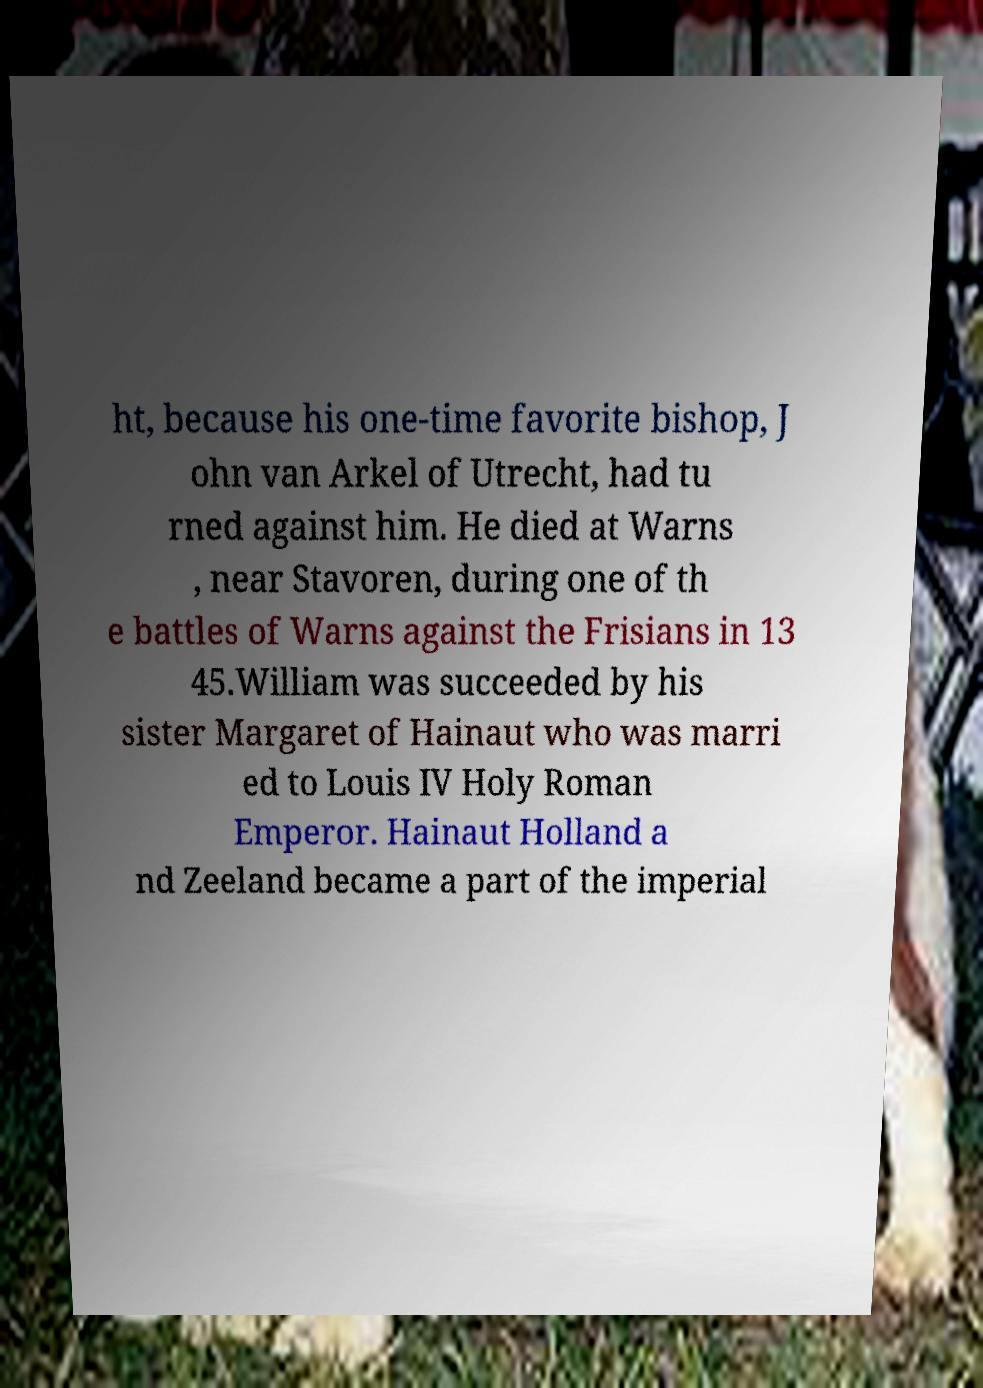There's text embedded in this image that I need extracted. Can you transcribe it verbatim? ht, because his one-time favorite bishop, J ohn van Arkel of Utrecht, had tu rned against him. He died at Warns , near Stavoren, during one of th e battles of Warns against the Frisians in 13 45.William was succeeded by his sister Margaret of Hainaut who was marri ed to Louis IV Holy Roman Emperor. Hainaut Holland a nd Zeeland became a part of the imperial 